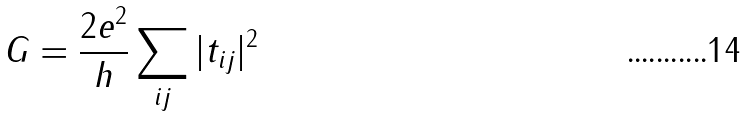<formula> <loc_0><loc_0><loc_500><loc_500>G = \frac { 2 e ^ { 2 } } { h } \sum _ { i j } | t _ { i j } | ^ { 2 }</formula> 